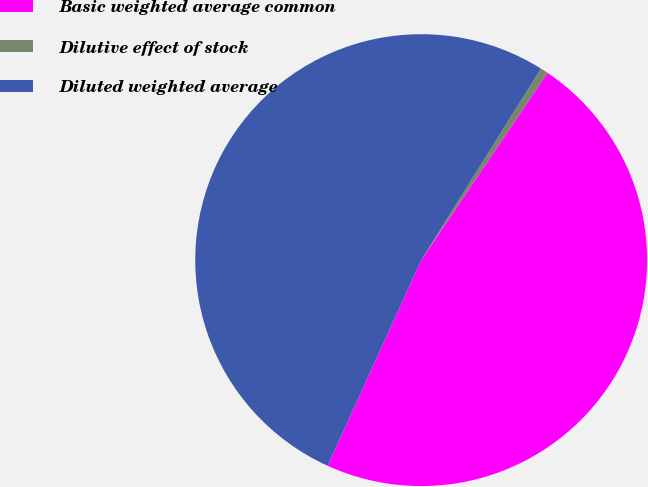Convert chart. <chart><loc_0><loc_0><loc_500><loc_500><pie_chart><fcel>Basic weighted average common<fcel>Dilutive effect of stock<fcel>Diluted weighted average<nl><fcel>47.36%<fcel>0.55%<fcel>52.1%<nl></chart> 